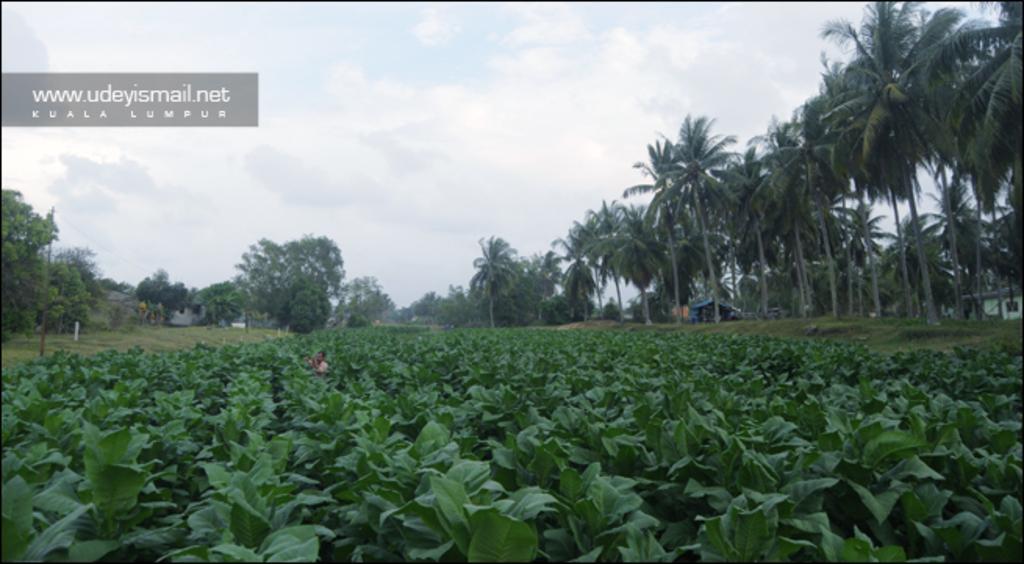In one or two sentences, can you explain what this image depicts? In this image there is a person standing in the middle of the crop, in the background of the image there are trees and houses. 